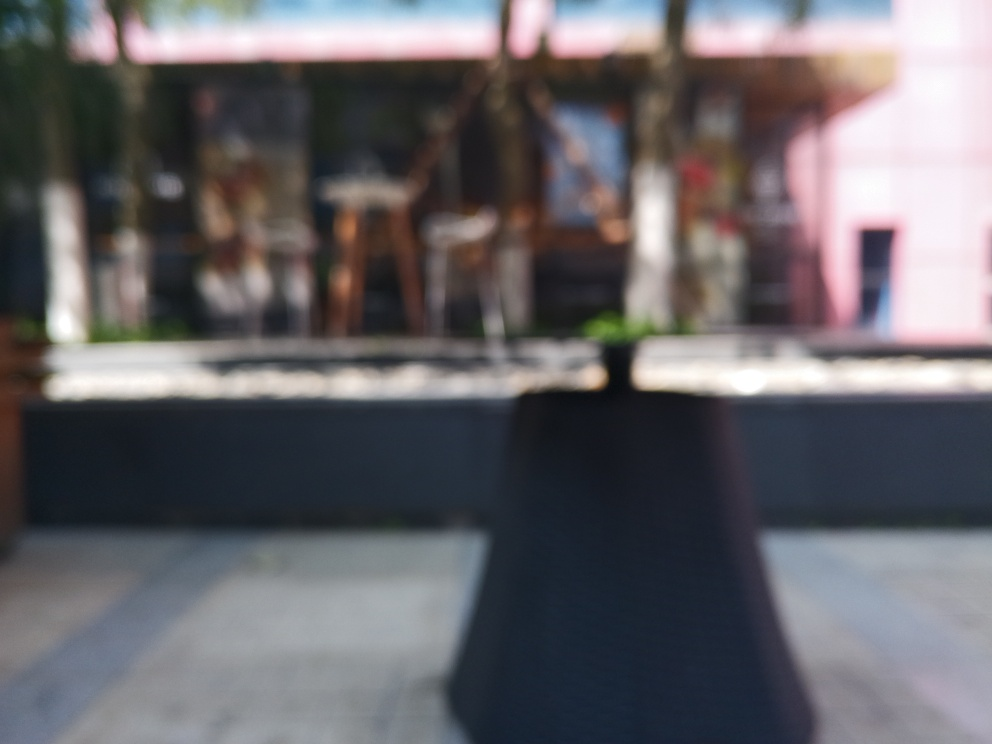Is the clarity of the image extremely poor?
 Yes 